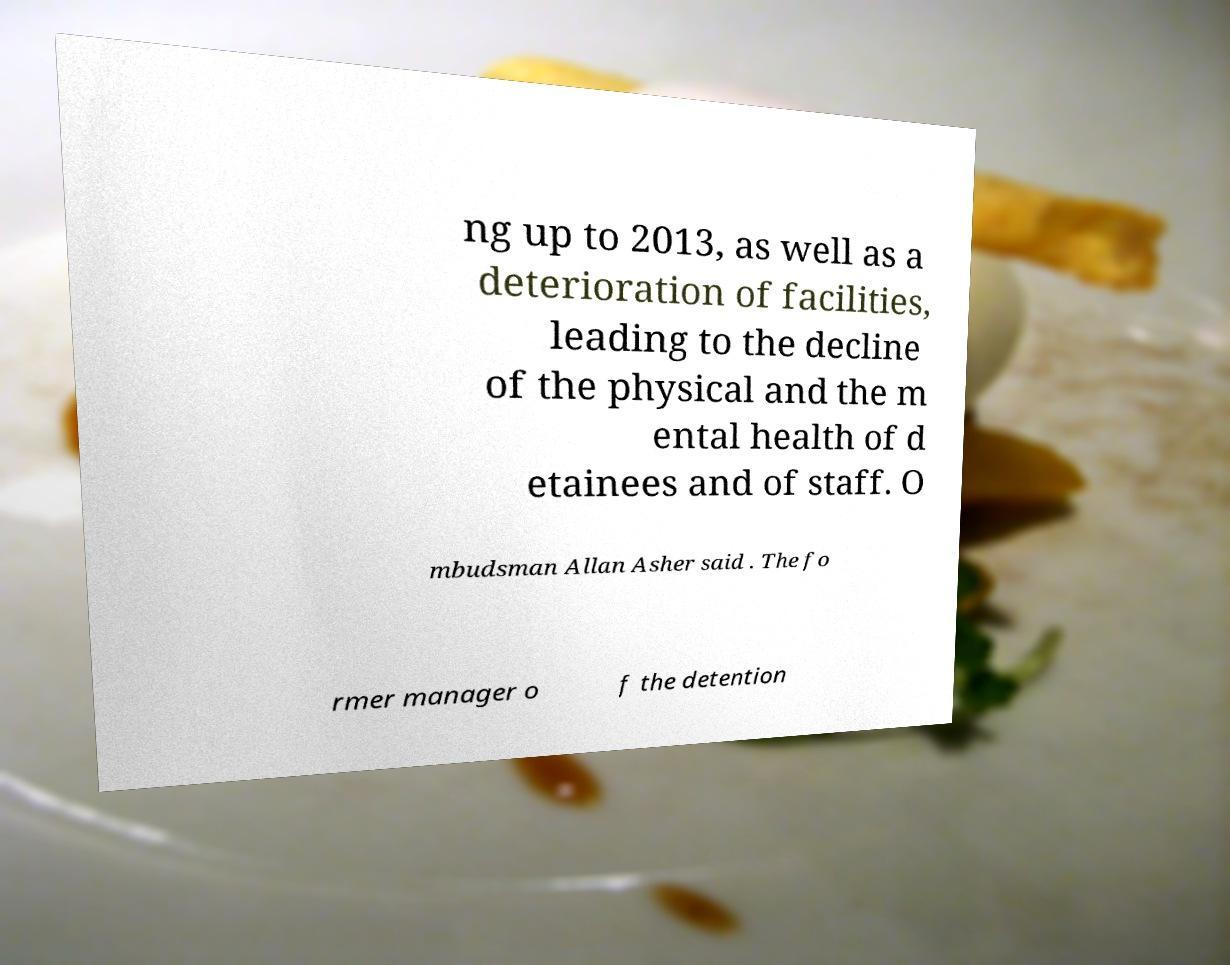What messages or text are displayed in this image? I need them in a readable, typed format. ng up to 2013, as well as a deterioration of facilities, leading to the decline of the physical and the m ental health of d etainees and of staff. O mbudsman Allan Asher said . The fo rmer manager o f the detention 